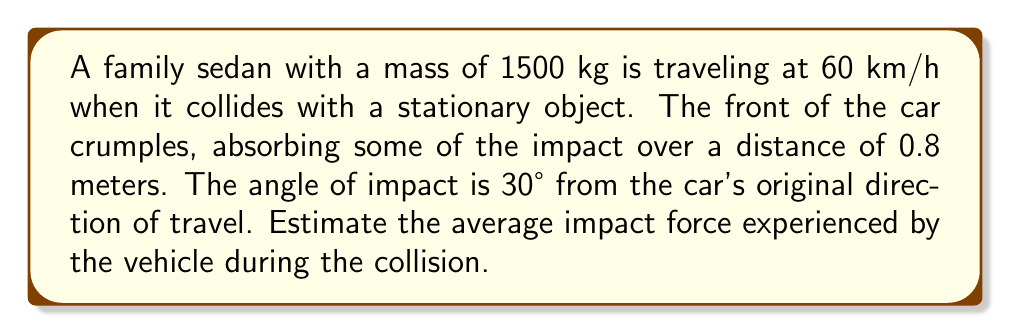What is the answer to this math problem? To solve this problem, we'll use trigonometric functions and the work-energy principle. Let's break it down step-by-step:

1) First, convert the car's speed from km/h to m/s:
   $$ 60 \frac{km}{h} \times \frac{1000 m}{1 km} \times \frac{1 h}{3600 s} = 16.67 m/s $$

2) Calculate the car's initial kinetic energy:
   $$ KE = \frac{1}{2}mv^2 = \frac{1}{2} \times 1500 \times 16.67^2 = 208,375 J $$

3) The work done by the impact force is equal to the change in kinetic energy. Since the car comes to a stop, all kinetic energy is lost:
   $$ W = F \times d = 208,375 J $$

4) The distance over which the force acts is not the full 0.8 m, but its component in the direction of the original velocity. We can find this using cosine:
   $$ d = 0.8 \times \cos(30°) = 0.8 \times \frac{\sqrt{3}}{2} = 0.693 m $$

5) Now we can solve for the average force:
   $$ F = \frac{W}{d} = \frac{208,375}{0.693} = 300,685 N $$

6) However, this is the force component in the original direction of travel. To find the total impact force, we need to divide by cosine of the impact angle:
   $$ F_{total} = \frac{F}{\cos(30°)} = \frac{300,685}{\frac{\sqrt{3}}{2}} = 347,228 N $$

Therefore, the estimated average impact force is approximately 347,228 N or 347 kN.
Answer: The estimated average impact force is 347 kN. 